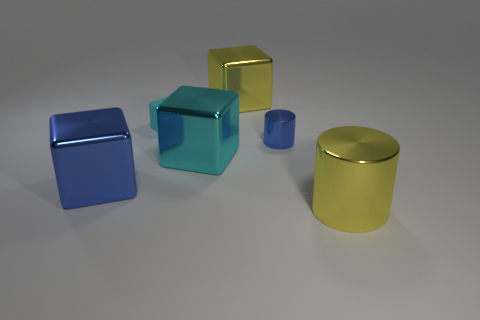Subtract 2 cubes. How many cubes are left? 2 Subtract all metallic cubes. How many cubes are left? 1 Add 1 large brown rubber balls. How many objects exist? 7 Subtract all purple blocks. Subtract all red balls. How many blocks are left? 4 Subtract all cubes. How many objects are left? 2 Add 1 tiny blue shiny cylinders. How many tiny blue shiny cylinders exist? 2 Subtract 0 purple blocks. How many objects are left? 6 Subtract all green rubber blocks. Subtract all big cyan objects. How many objects are left? 5 Add 2 yellow shiny cylinders. How many yellow shiny cylinders are left? 3 